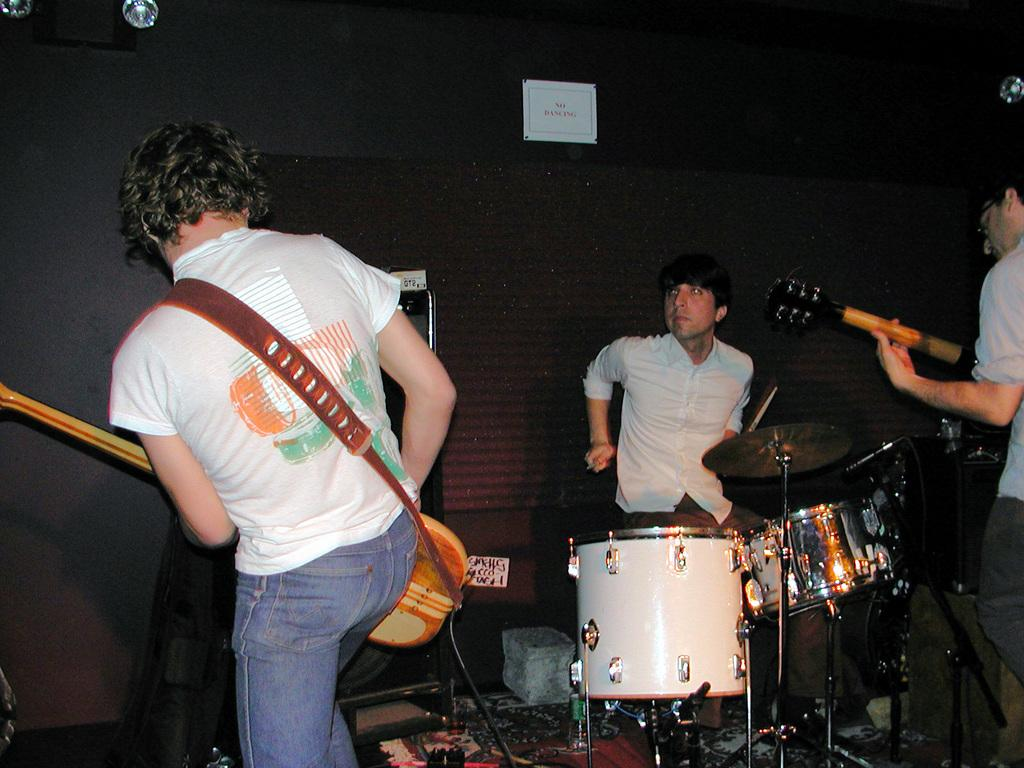How many people are in the image? There are three men in the image. What are the men doing in the image? The men are playing musical instruments. What are the men wearing in the image? The men are wearing white shirts. What can be seen in the background of the image? There is a paper note in the background. What else is visible in the image? There are lights visible in the image. What type of mitten is the man on the left wearing in the image? There are no mittens present in the image; the men are wearing white shirts. How does the moon affect the lighting in the image? The image does not depict the moon, so its effect on the lighting cannot be determined. 